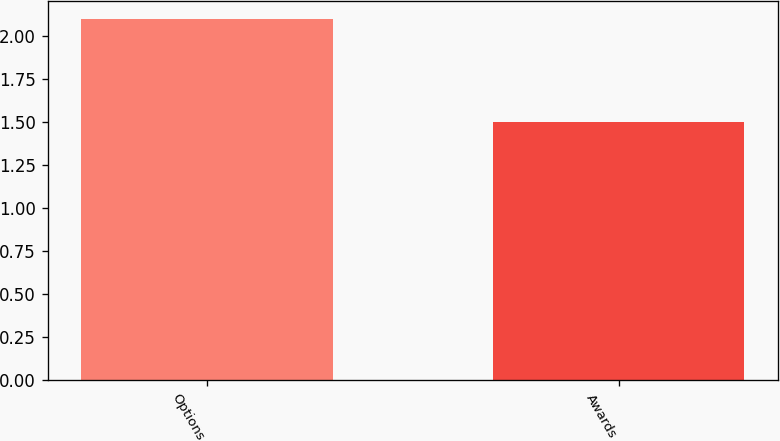Convert chart. <chart><loc_0><loc_0><loc_500><loc_500><bar_chart><fcel>Options<fcel>Awards<nl><fcel>2.1<fcel>1.5<nl></chart> 